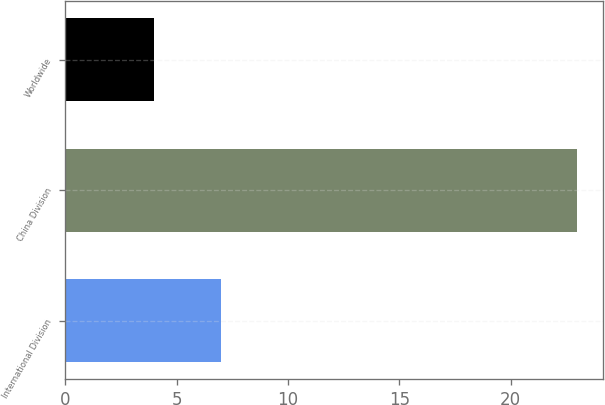Convert chart. <chart><loc_0><loc_0><loc_500><loc_500><bar_chart><fcel>International Division<fcel>China Division<fcel>Worldwide<nl><fcel>7<fcel>23<fcel>4<nl></chart> 